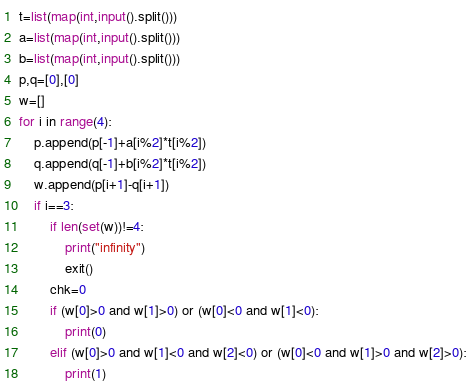<code> <loc_0><loc_0><loc_500><loc_500><_Python_>t=list(map(int,input().split()))
a=list(map(int,input().split()))
b=list(map(int,input().split()))
p,q=[0],[0]
w=[]
for i in range(4):
    p.append(p[-1]+a[i%2]*t[i%2])
    q.append(q[-1]+b[i%2]*t[i%2])
    w.append(p[i+1]-q[i+1])
    if i==3:
        if len(set(w))!=4:
            print("infinity")
            exit()
        chk=0
        if (w[0]>0 and w[1]>0) or (w[0]<0 and w[1]<0):
            print(0)
        elif (w[0]>0 and w[1]<0 and w[2]<0) or (w[0]<0 and w[1]>0 and w[2]>0):
            print(1)</code> 